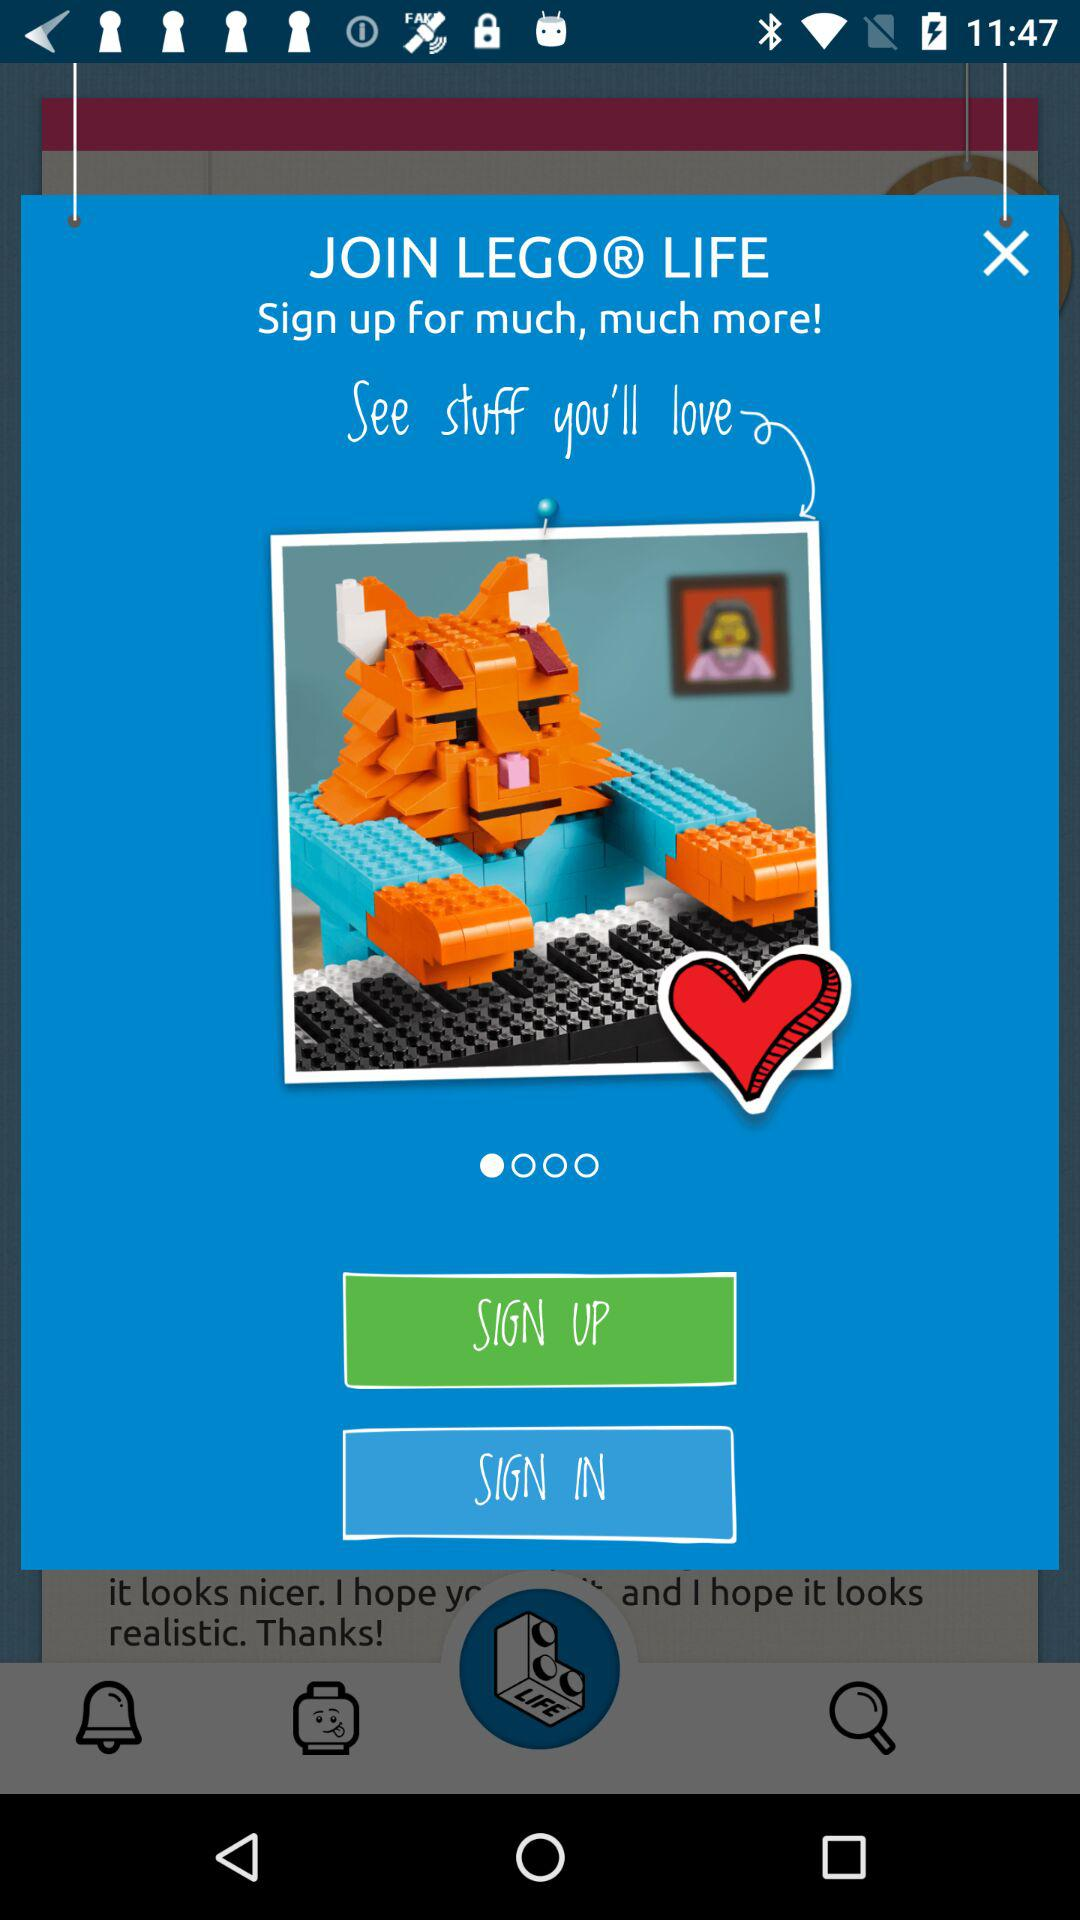What is the name of the application? The name of the application is "LEGO LIFE". 